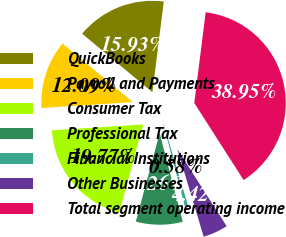Convert chart to OTSL. <chart><loc_0><loc_0><loc_500><loc_500><pie_chart><fcel>QuickBooks<fcel>Payroll and Payments<fcel>Consumer Tax<fcel>Professional Tax<fcel>Financial Institutions<fcel>Other Businesses<fcel>Total segment operating income<nl><fcel>15.93%<fcel>12.09%<fcel>19.77%<fcel>8.26%<fcel>0.58%<fcel>4.42%<fcel>38.95%<nl></chart> 